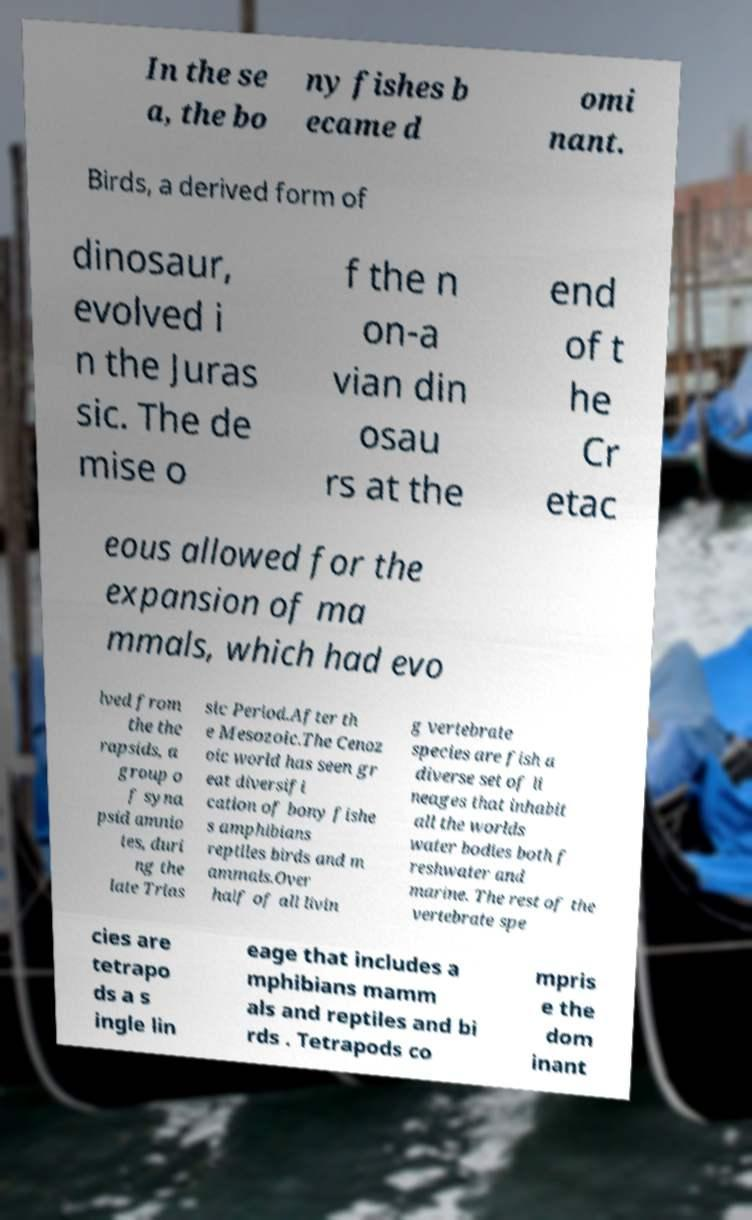I need the written content from this picture converted into text. Can you do that? In the se a, the bo ny fishes b ecame d omi nant. Birds, a derived form of dinosaur, evolved i n the Juras sic. The de mise o f the n on-a vian din osau rs at the end of t he Cr etac eous allowed for the expansion of ma mmals, which had evo lved from the the rapsids, a group o f syna psid amnio tes, duri ng the late Trias sic Period.After th e Mesozoic.The Cenoz oic world has seen gr eat diversifi cation of bony fishe s amphibians reptiles birds and m ammals.Over half of all livin g vertebrate species are fish a diverse set of li neages that inhabit all the worlds water bodies both f reshwater and marine. The rest of the vertebrate spe cies are tetrapo ds a s ingle lin eage that includes a mphibians mamm als and reptiles and bi rds . Tetrapods co mpris e the dom inant 